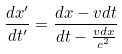<formula> <loc_0><loc_0><loc_500><loc_500>\frac { d x ^ { \prime } } { d t ^ { \prime } } = \frac { d x - v d t } { d t - \frac { v d x } { c ^ { 2 } } }</formula> 